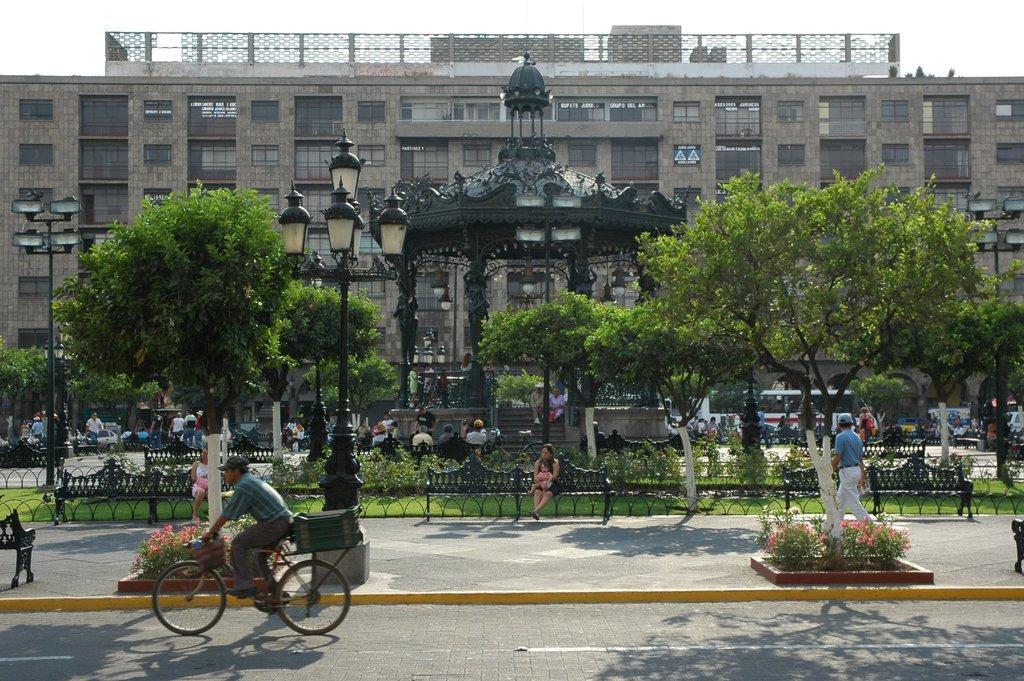In one or two sentences, can you explain what this image depicts? In the left bottom, a person is riding a bicycle. In the right bottom, a person is walking on the road. In the middle a woman is sitting on the bench with a baby in her hand. Both side of the image middle, there are trees visible. In the background, a building is visible. On the top, a sky blue in color is there. In the middle, there are group of people sitting on the bench and some are walking on the road and there are cars, buses moving on the road. This image is taken during day time on the road. 